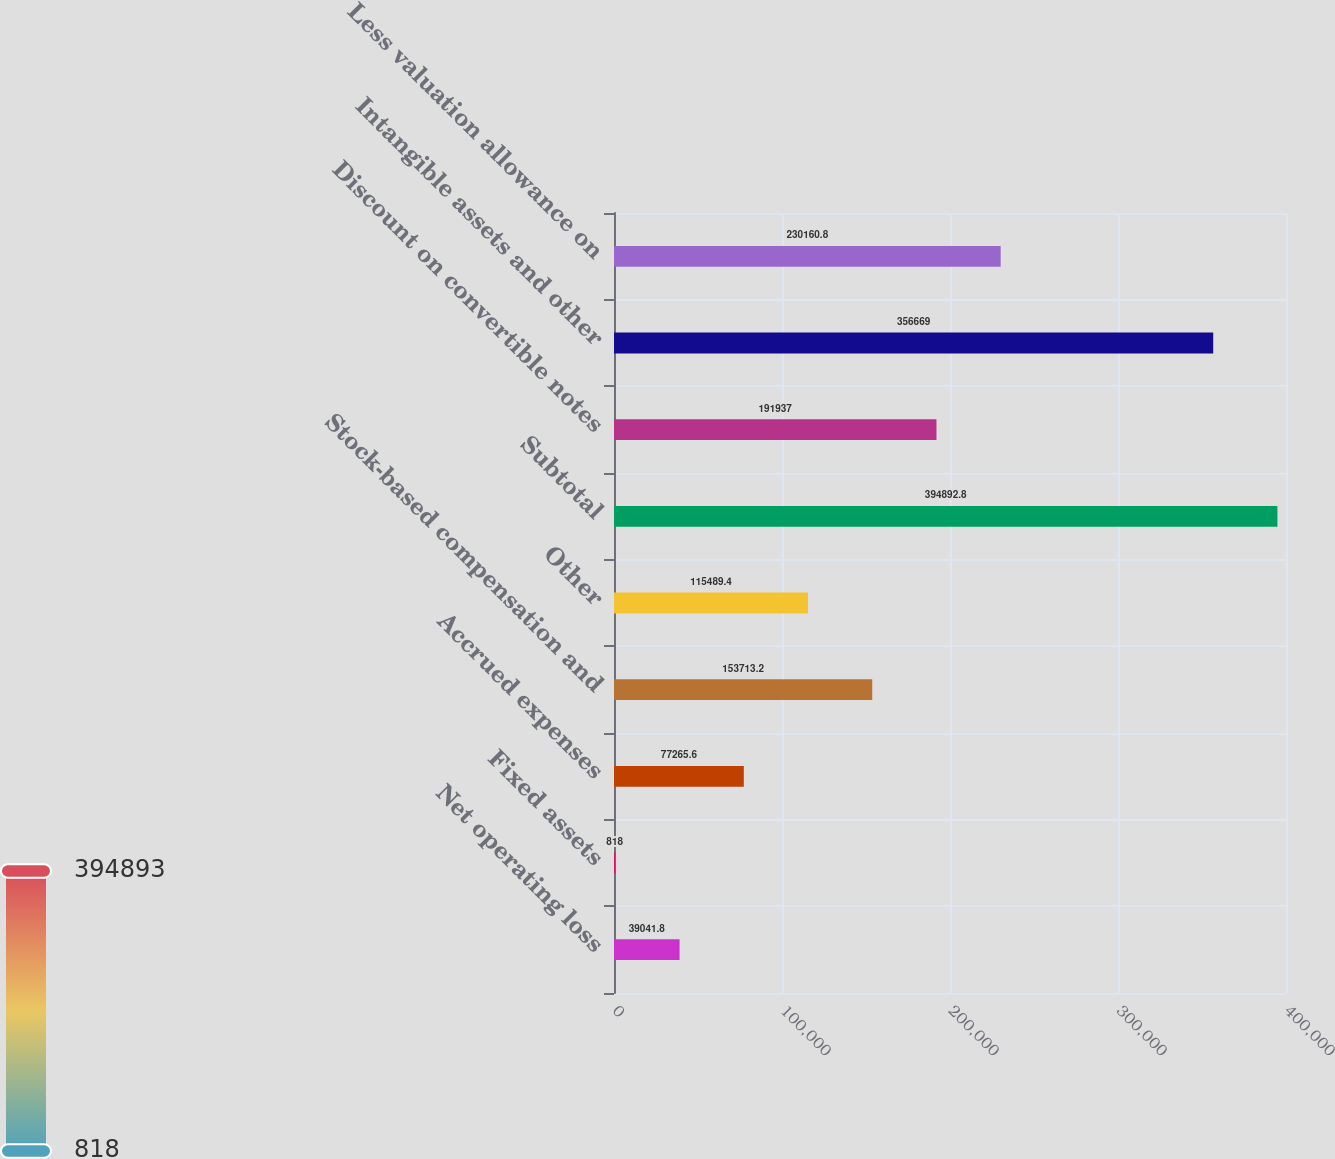Convert chart to OTSL. <chart><loc_0><loc_0><loc_500><loc_500><bar_chart><fcel>Net operating loss<fcel>Fixed assets<fcel>Accrued expenses<fcel>Stock-based compensation and<fcel>Other<fcel>Subtotal<fcel>Discount on convertible notes<fcel>Intangible assets and other<fcel>Less valuation allowance on<nl><fcel>39041.8<fcel>818<fcel>77265.6<fcel>153713<fcel>115489<fcel>394893<fcel>191937<fcel>356669<fcel>230161<nl></chart> 